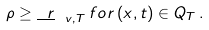<formula> <loc_0><loc_0><loc_500><loc_500>\rho \geq \underline { \ r } _ { \ v , T } \, f o r \, ( x , t ) \in Q _ { T } \, .</formula> 